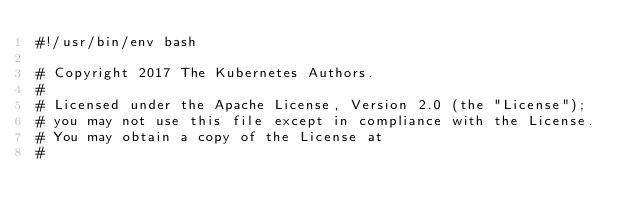Convert code to text. <code><loc_0><loc_0><loc_500><loc_500><_Bash_>#!/usr/bin/env bash

# Copyright 2017 The Kubernetes Authors.
#
# Licensed under the Apache License, Version 2.0 (the "License");
# you may not use this file except in compliance with the License.
# You may obtain a copy of the License at
#</code> 